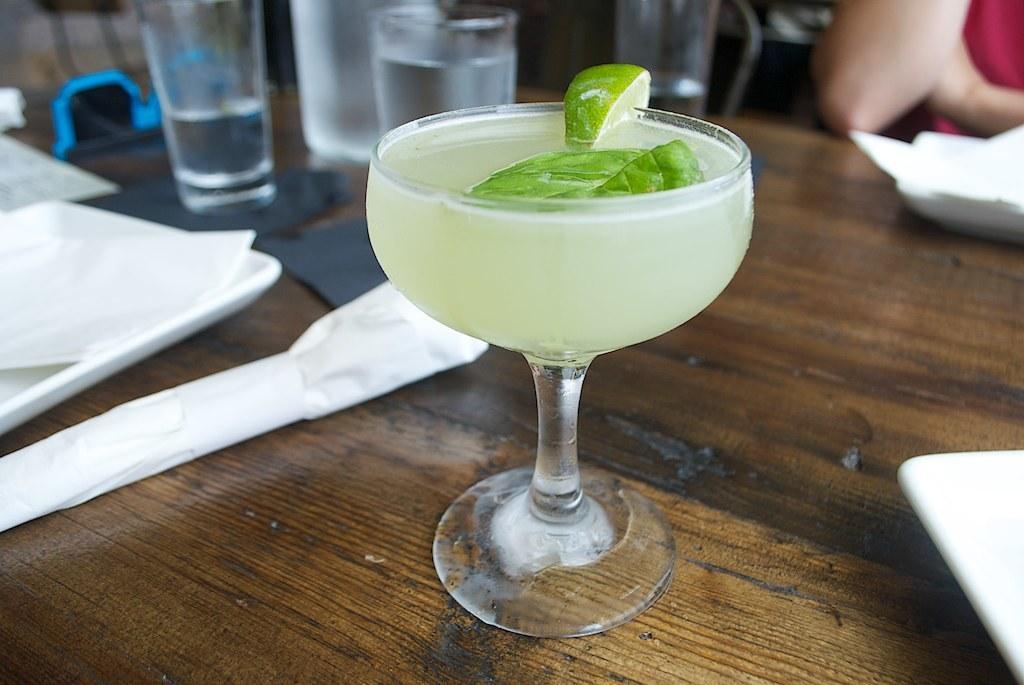In one or two sentences, can you explain what this image depicts? In this picture we can see the lemon cocktail glass placed on the wooden table top. Beside there are some water glasses and white tray. 